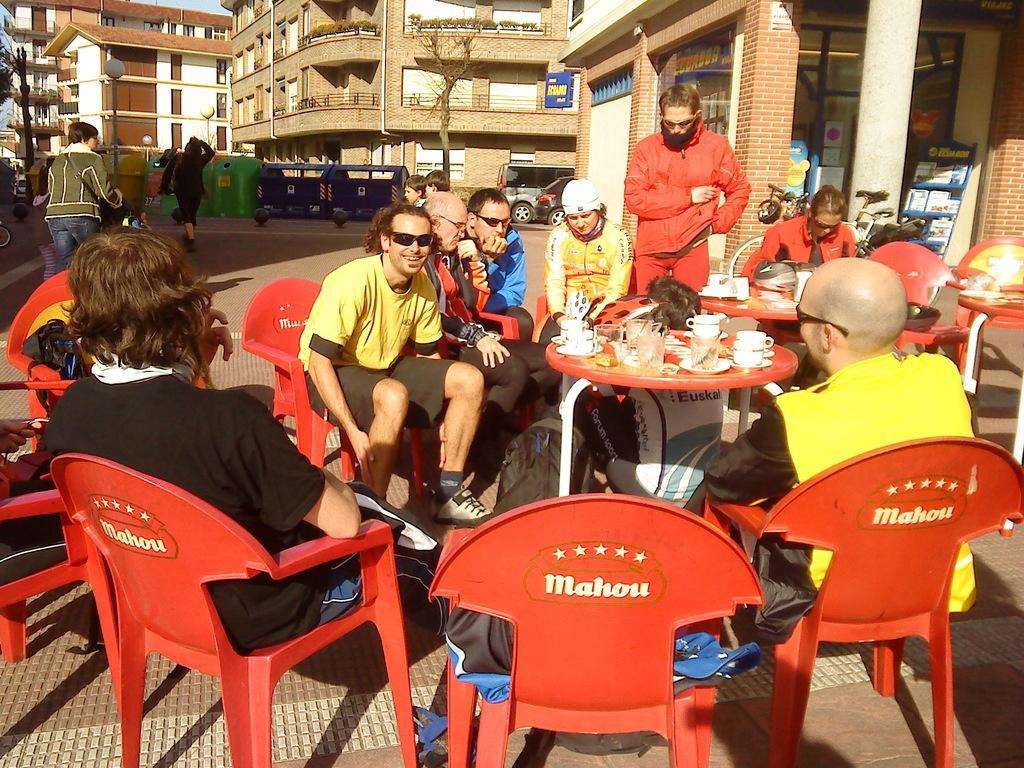In one or two sentences, can you explain what this image depicts? In this picture we can see group of people sitting on chair and in front of them there is table and on table we can see glass, cup, saucer, box and in background we can see building with windows,balcony, pole, light, vehicles, pillar, book stand. 